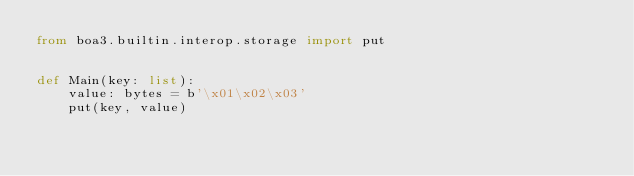<code> <loc_0><loc_0><loc_500><loc_500><_Python_>from boa3.builtin.interop.storage import put


def Main(key: list):
    value: bytes = b'\x01\x02\x03'
    put(key, value)
</code> 